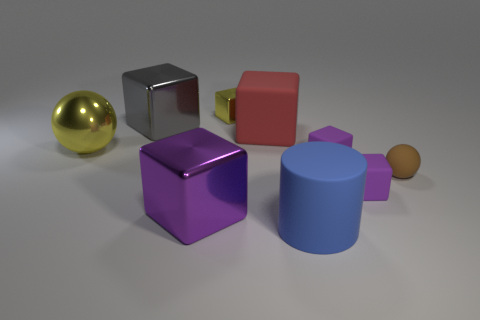If the light source were to move towards the left side, how might the shadows of the objects change? If the light shifted to the left, the objects' shadows would alter direction, extending more towards the right. This would create longer shadows for the sphere, the cylinders, and cubes, altering the tonal contrast and spatial relationships on the surface. 